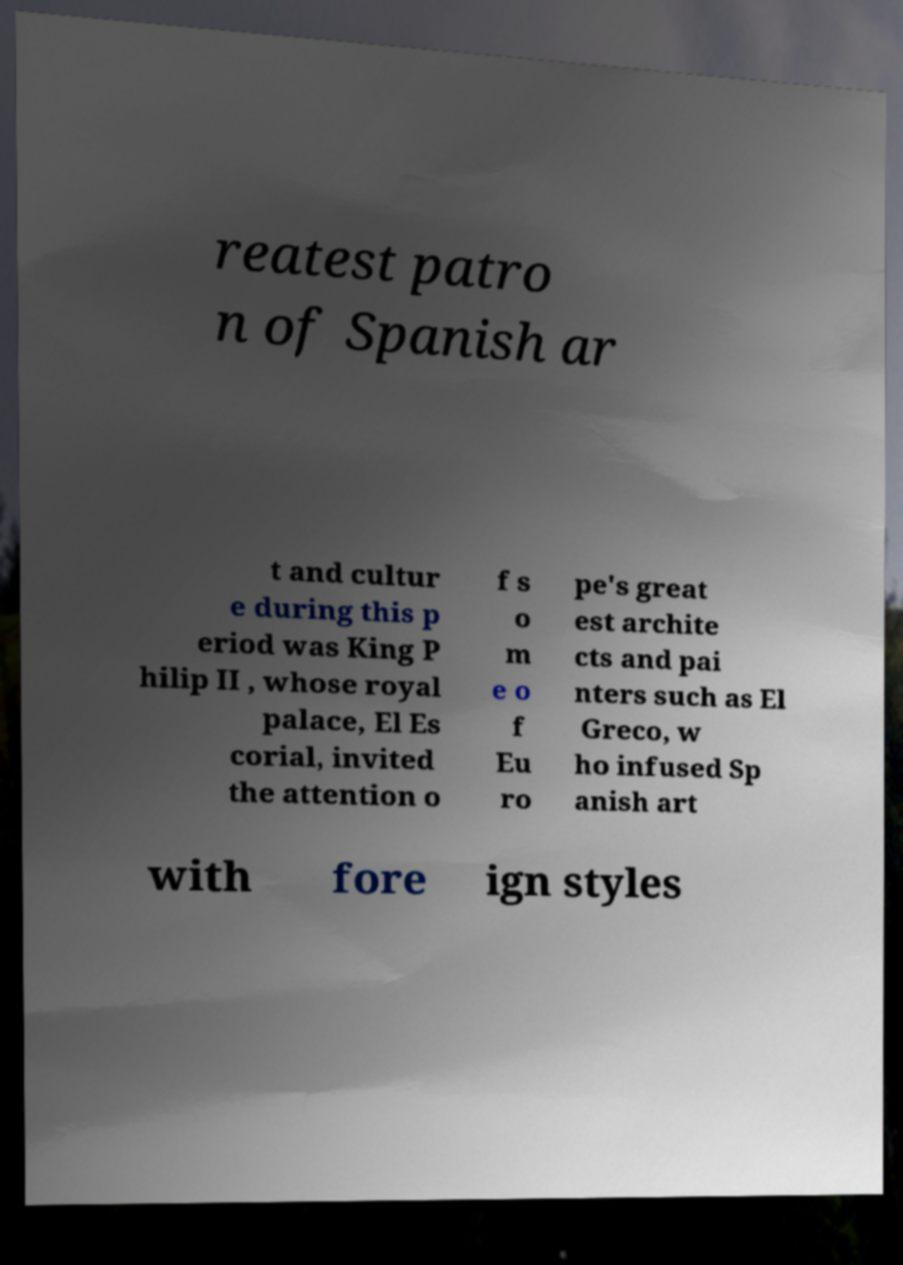Could you assist in decoding the text presented in this image and type it out clearly? reatest patro n of Spanish ar t and cultur e during this p eriod was King P hilip II , whose royal palace, El Es corial, invited the attention o f s o m e o f Eu ro pe's great est archite cts and pai nters such as El Greco, w ho infused Sp anish art with fore ign styles 